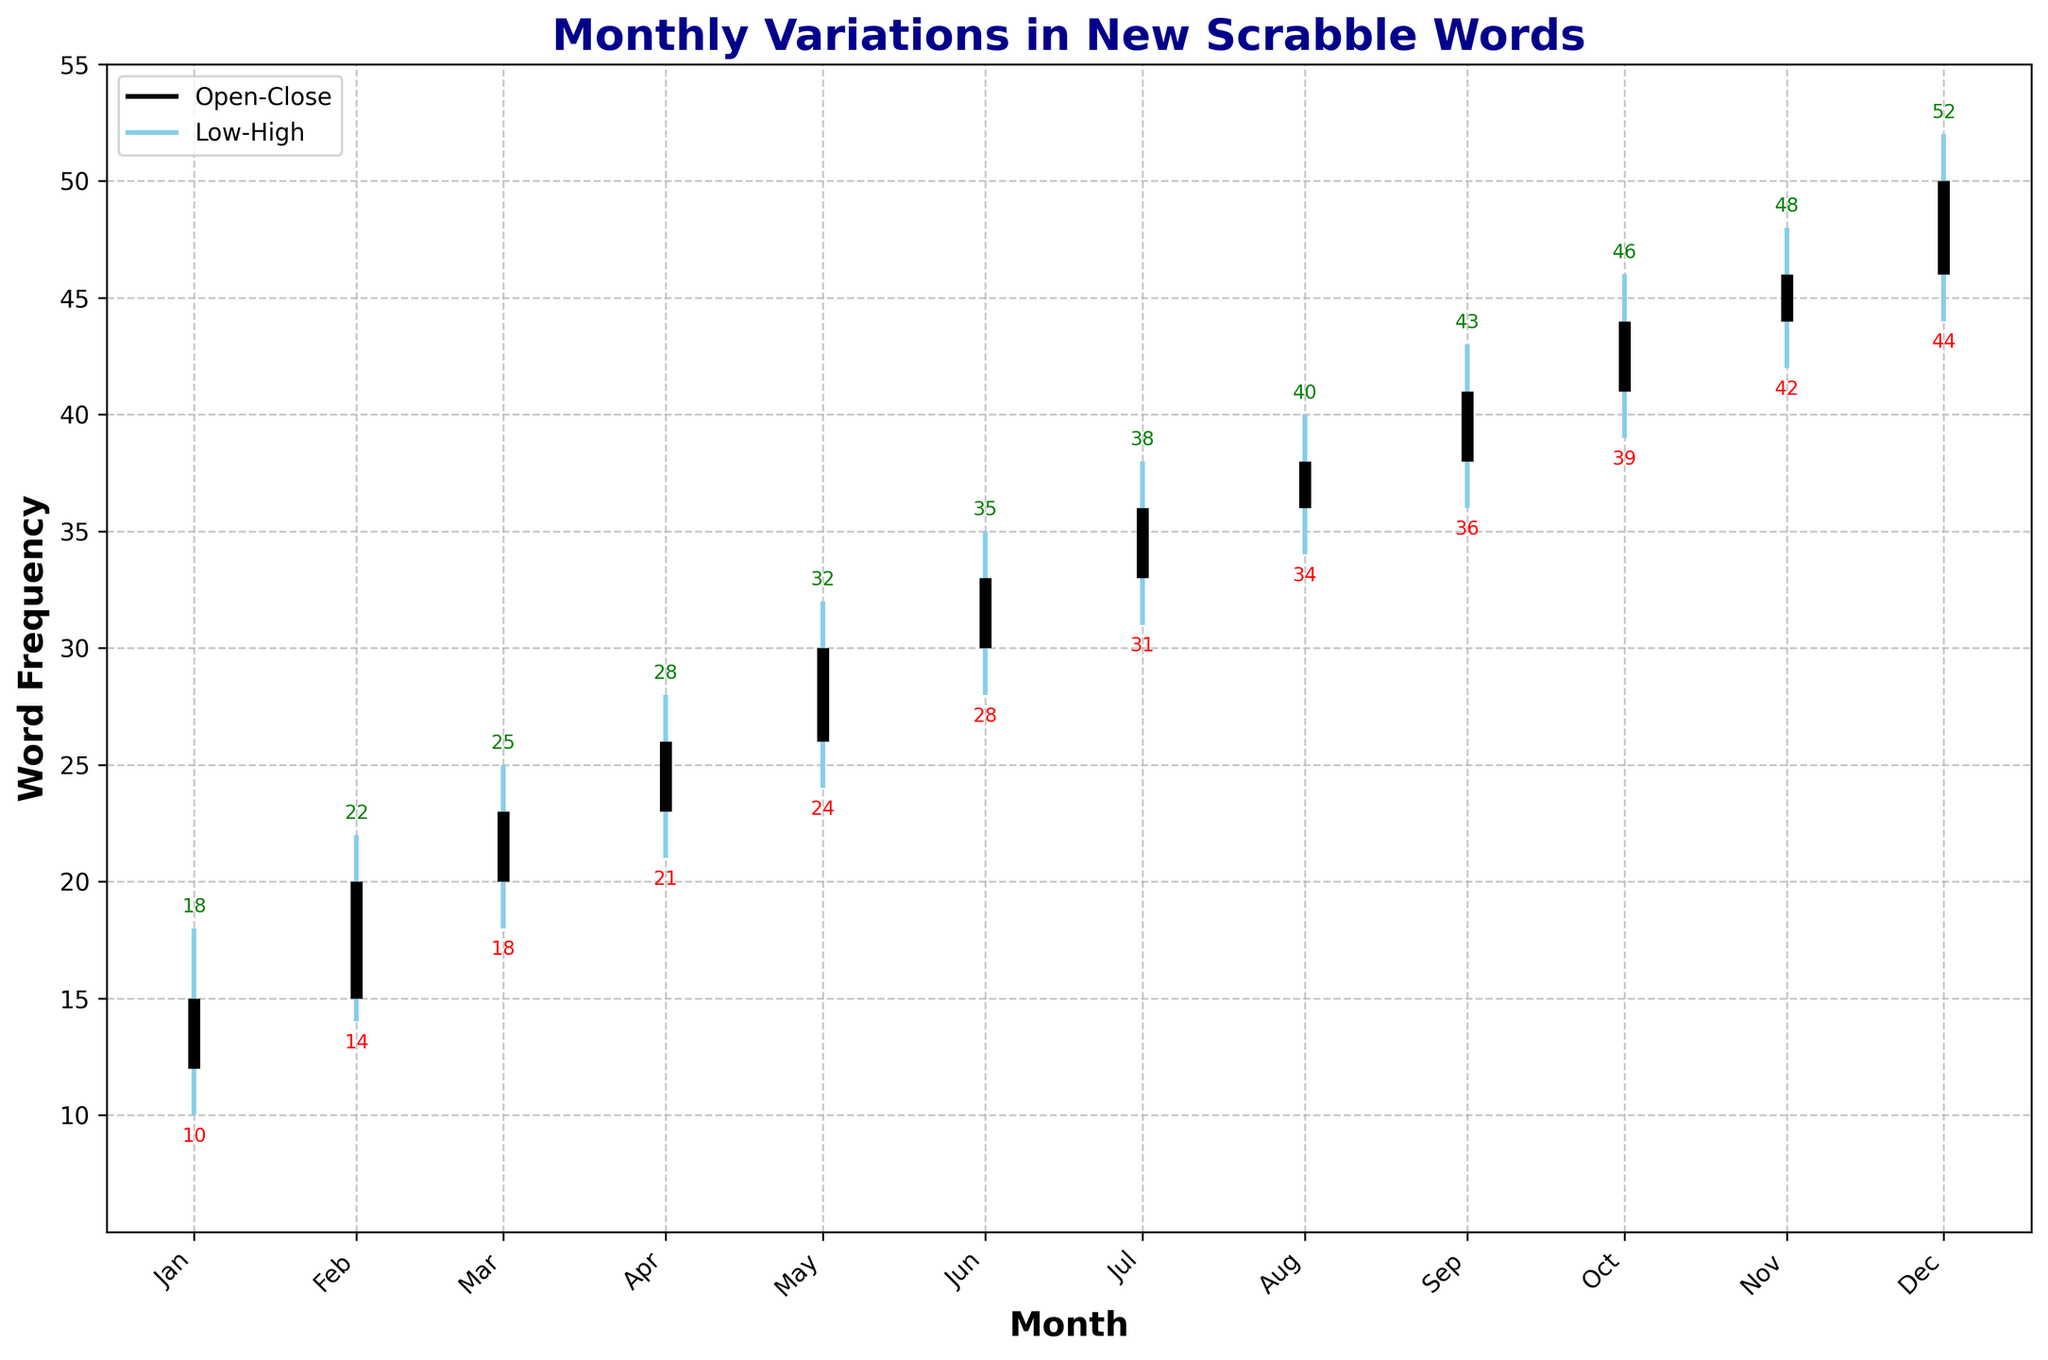what is the range of new words added in May? The range is the difference between the highest and lowest values in May. From the chart, the highest value (High) is 32, and the lowest value (Low) is 24. So, the range is 32 - 24.
Answer: 8 Which month had the highest number of new words added? To determine this, look for the highest "High" value on the chart. The highest number is 52, which occurred in December.
Answer: December Which month had the smallest difference between the opening and closing number of new words? To find this, calculate the difference between the Open and Close values for each month. The differences are as follows: January (3), February (5), March (3), April (3), May (4), June (3), July (3), August (2), September (3), October (3), November (2), December (4). The smallest difference is 2, which occurs in both August and November.
Answer: August and November What is the average closing value for the first quarter (January, February, March)? The first quarter consists of January, February, and March. Sum the closing values (15 + 20 + 23) and divide by 3.
Answer: 19.33 Between which two consecutive months is the increase in the number of words added the greatest? Look for the maximum increase in Close values between consecutive months. The largest increase is from July (36) to August (38), which is an increase of 9. The raw data confirms the increase is largest here.
Answer: July to August What is the highest closing value and in which month does it occur? Looking at the chart, the highest closing value is 50, which occurs in December.
Answer: December In which month was the lowest number of new words added to the dictionary? Identify the lowest Low value on the chart. The lowest value is 10, which occurred in January.
Answer: January 